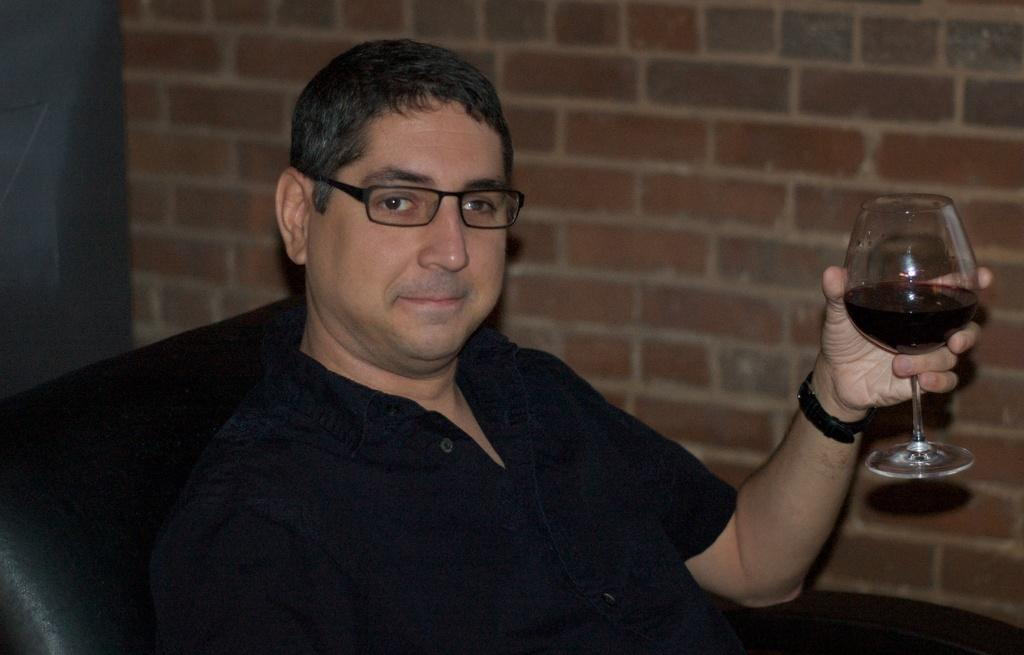Who is present in the image? There is a man in the image. What is the man doing in the image? The man is sitting on a chair in the image. What is the man holding in the image? The man is holding a glass in the image. What can be seen in the background of the image? There is a wall in the background of the image. How many babies are visible in the image? There are no babies present in the image; it features a man sitting on a chair and holding a glass. 